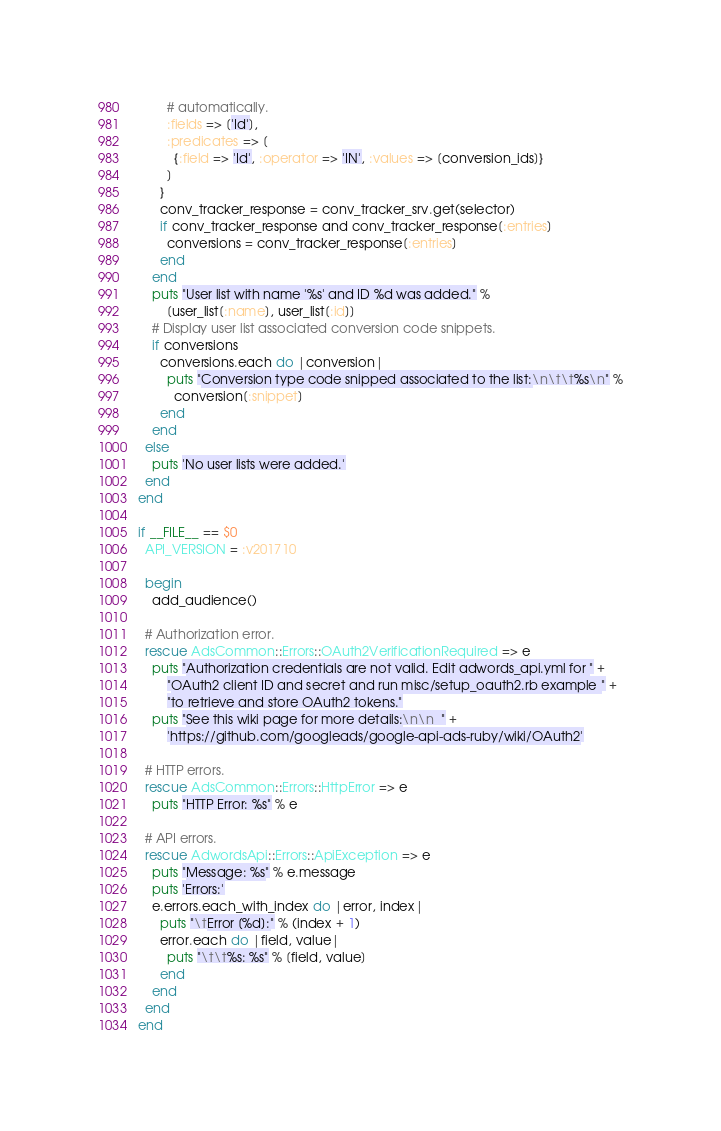<code> <loc_0><loc_0><loc_500><loc_500><_Ruby_>        # automatically.
        :fields => ['Id'],
        :predicates => [
          {:field => 'Id', :operator => 'IN', :values => [conversion_ids]}
        ]
      }
      conv_tracker_response = conv_tracker_srv.get(selector)
      if conv_tracker_response and conv_tracker_response[:entries]
        conversions = conv_tracker_response[:entries]
      end
    end
    puts "User list with name '%s' and ID %d was added." %
        [user_list[:name], user_list[:id]]
    # Display user list associated conversion code snippets.
    if conversions
      conversions.each do |conversion|
        puts "Conversion type code snipped associated to the list:\n\t\t%s\n" %
          conversion[:snippet]
      end
    end
  else
    puts 'No user lists were added.'
  end
end

if __FILE__ == $0
  API_VERSION = :v201710

  begin
    add_audience()

  # Authorization error.
  rescue AdsCommon::Errors::OAuth2VerificationRequired => e
    puts "Authorization credentials are not valid. Edit adwords_api.yml for " +
        "OAuth2 client ID and secret and run misc/setup_oauth2.rb example " +
        "to retrieve and store OAuth2 tokens."
    puts "See this wiki page for more details:\n\n  " +
        'https://github.com/googleads/google-api-ads-ruby/wiki/OAuth2'

  # HTTP errors.
  rescue AdsCommon::Errors::HttpError => e
    puts "HTTP Error: %s" % e

  # API errors.
  rescue AdwordsApi::Errors::ApiException => e
    puts "Message: %s" % e.message
    puts 'Errors:'
    e.errors.each_with_index do |error, index|
      puts "\tError [%d]:" % (index + 1)
      error.each do |field, value|
        puts "\t\t%s: %s" % [field, value]
      end
    end
  end
end
</code> 